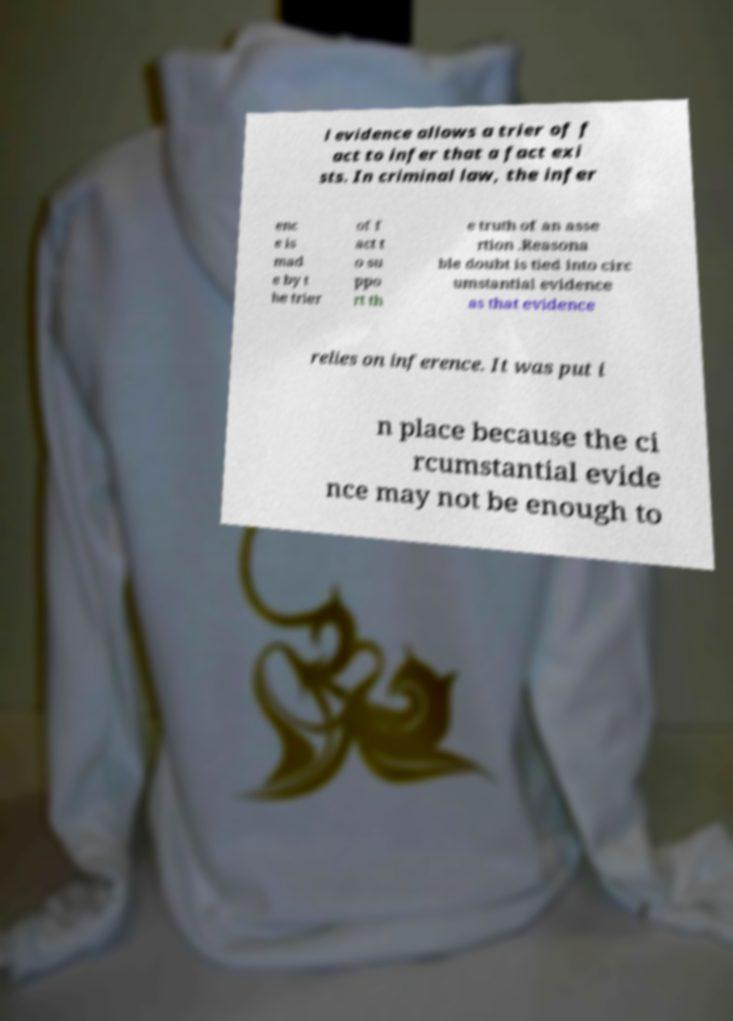I need the written content from this picture converted into text. Can you do that? l evidence allows a trier of f act to infer that a fact exi sts. In criminal law, the infer enc e is mad e by t he trier of f act t o su ppo rt th e truth of an asse rtion .Reasona ble doubt is tied into circ umstantial evidence as that evidence relies on inference. It was put i n place because the ci rcumstantial evide nce may not be enough to 